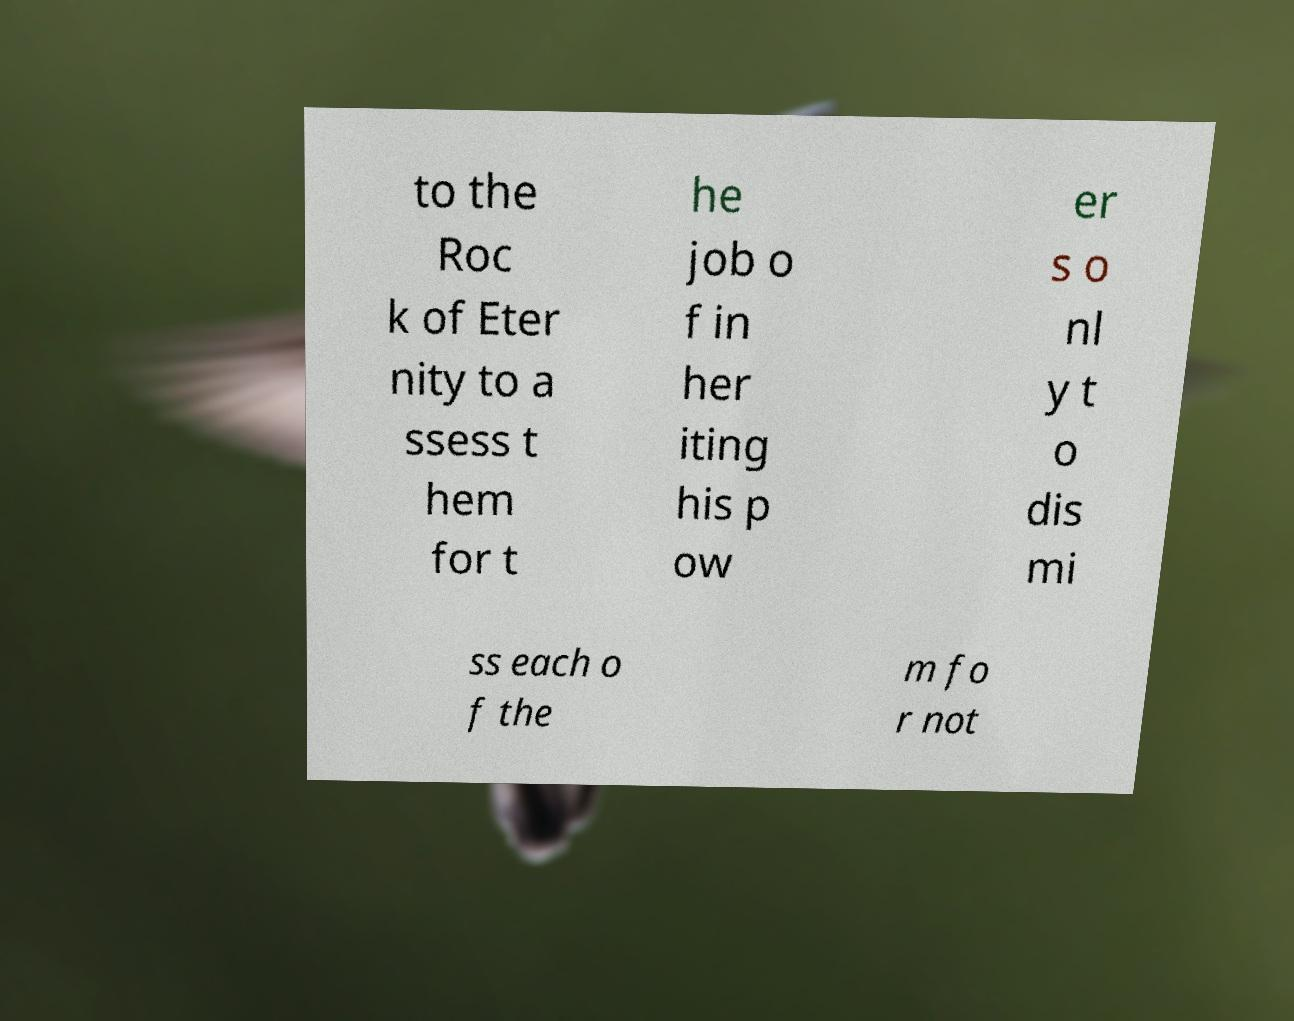I need the written content from this picture converted into text. Can you do that? to the Roc k of Eter nity to a ssess t hem for t he job o f in her iting his p ow er s o nl y t o dis mi ss each o f the m fo r not 